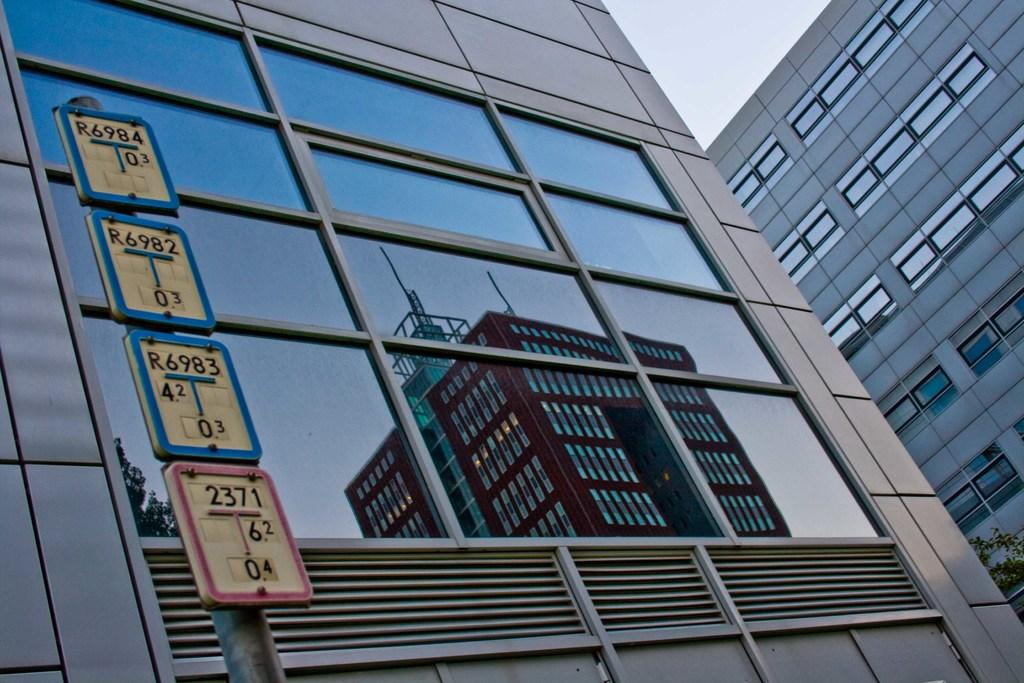What type of structures can be seen in the image? There are buildings in the image. What is attached to the pole in the image? There is a pole with boards attached to it in the image. What is written on the boards? Words are written on the boards. What part of the natural environment is visible in the image? The sky is visible in the image. Can you see a kitty playing with a wristwatch on the pole in the image? There is no kitty or wristwatch present in the image. What type of airport is visible in the image? There is no airport present in the image. 